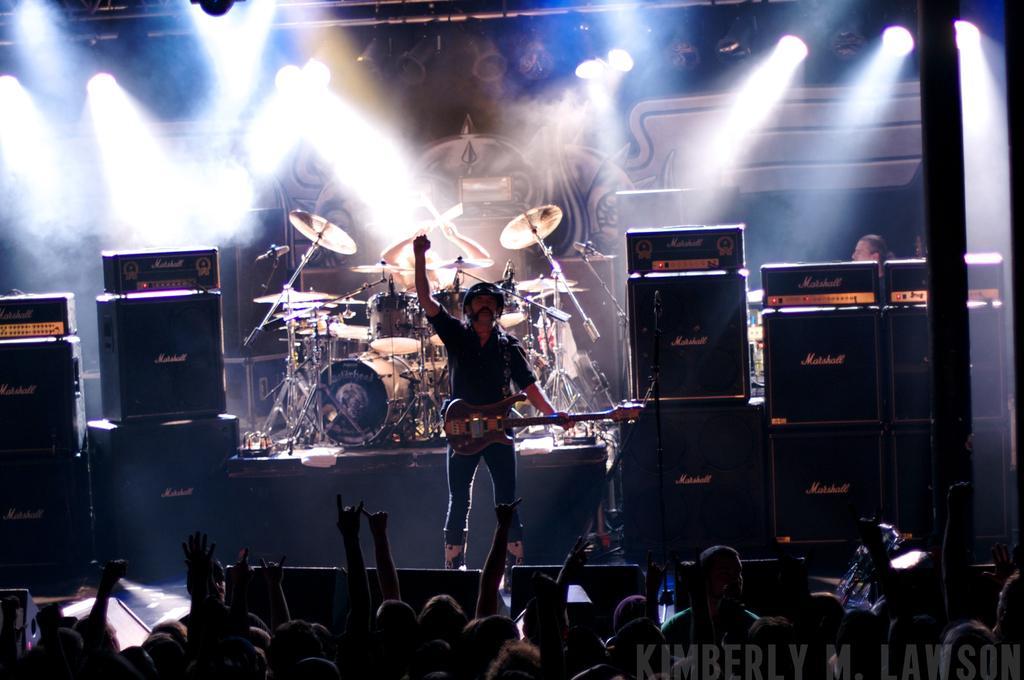Can you describe this image briefly? In this image we can see a person standing and holding a musical instrument. And we can see the other musical instruments. And we can see the speakers. And we can see the audience. And we can see some text in the bottom right hand corner. And we can see the lights 